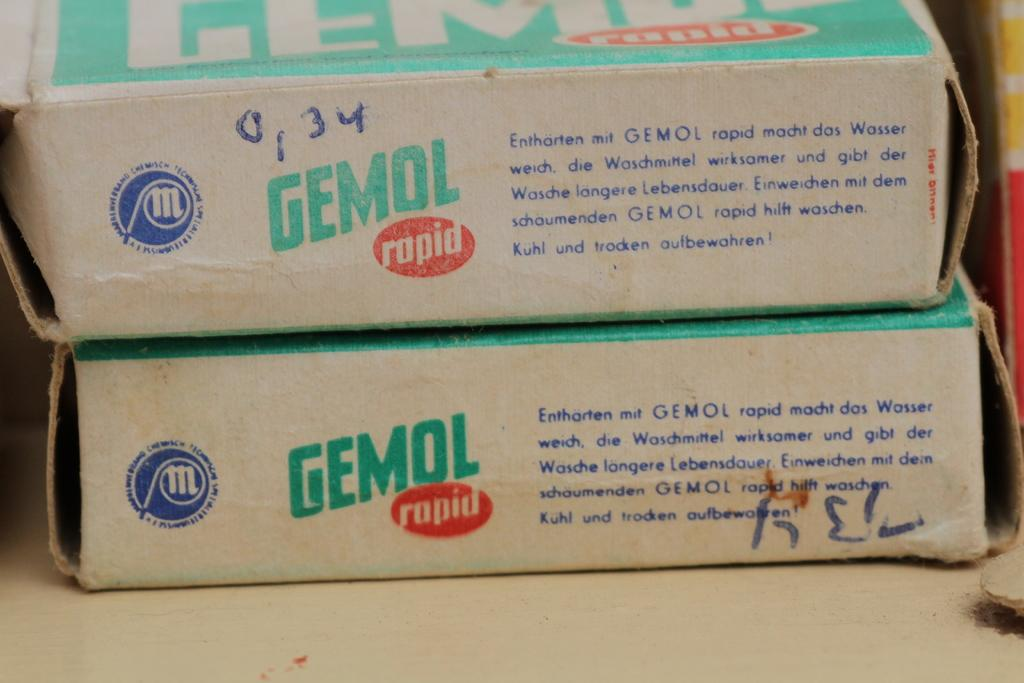<image>
Summarize the visual content of the image. Two boxes of Gemol Rapid stacked on top of each other. 